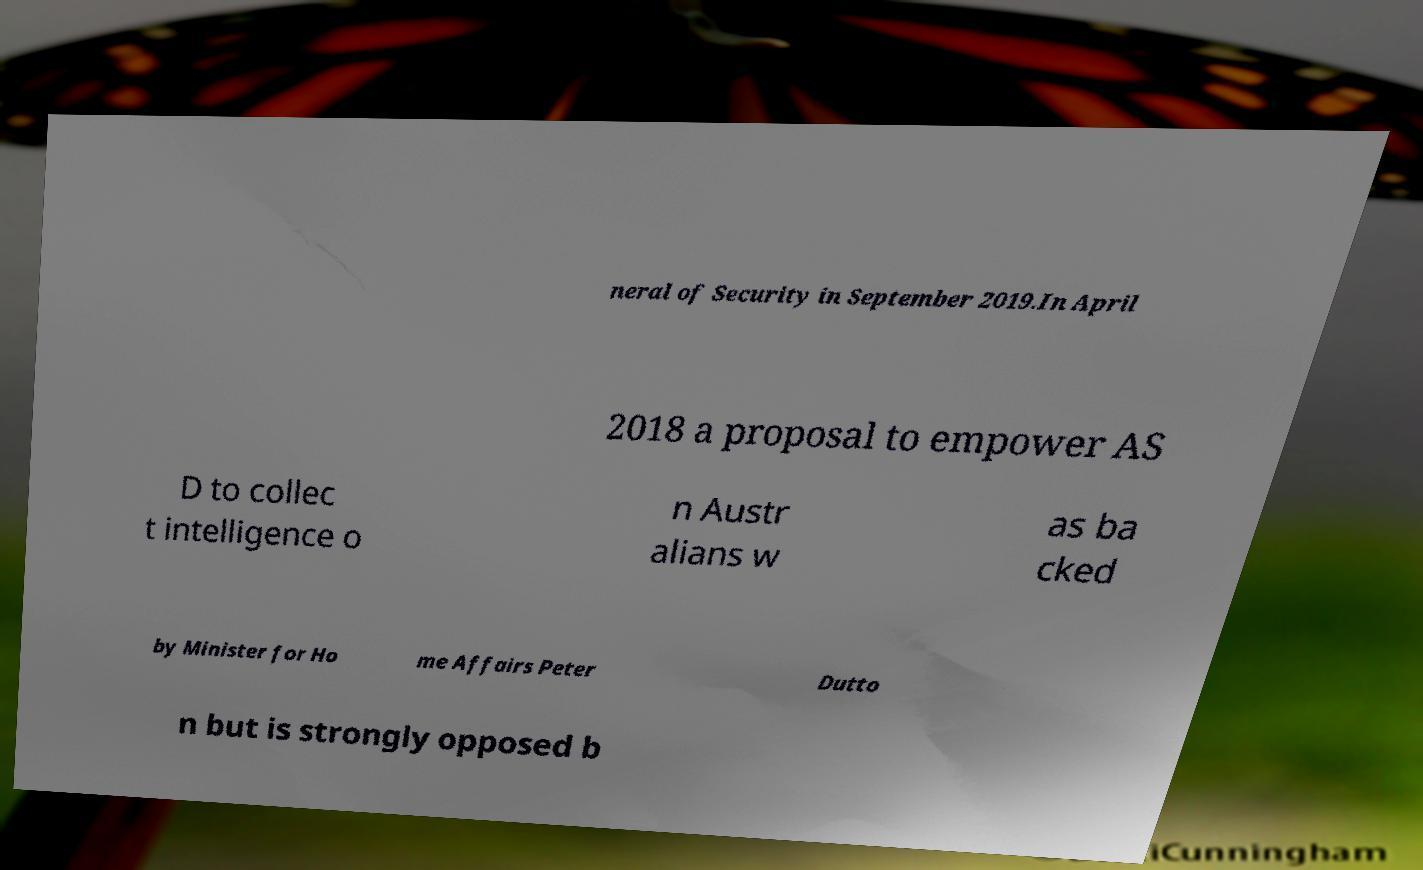What messages or text are displayed in this image? I need them in a readable, typed format. neral of Security in September 2019.In April 2018 a proposal to empower AS D to collec t intelligence o n Austr alians w as ba cked by Minister for Ho me Affairs Peter Dutto n but is strongly opposed b 